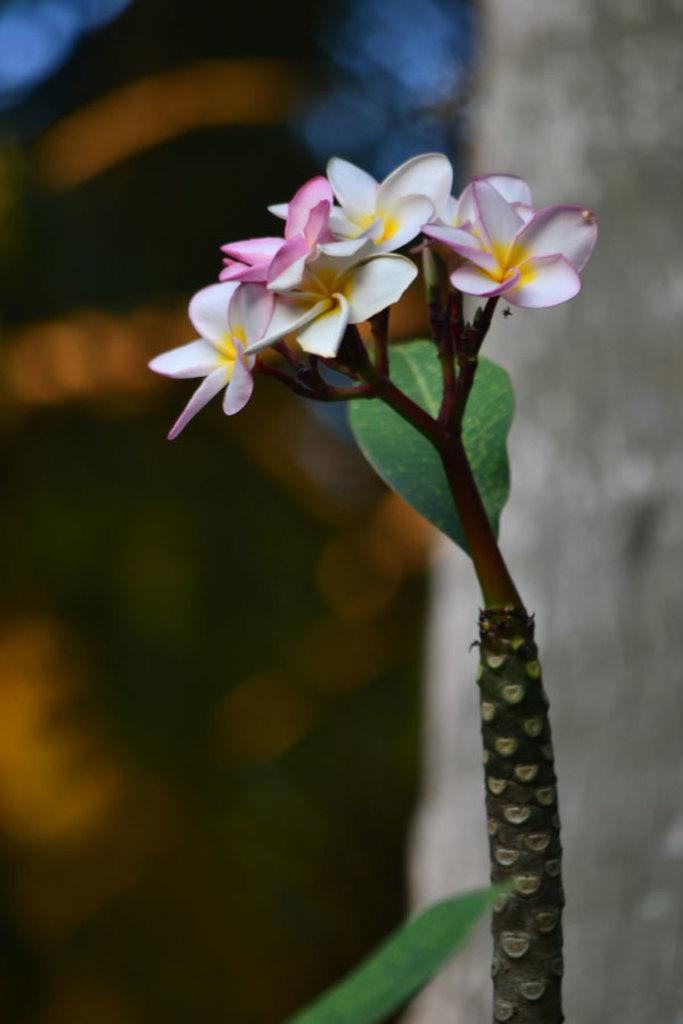What is the main subject of the image? There is a plant with flowers in the center of the image. Can you describe the background of the image? The background of the image is blurred. What type of mailbox can be seen in the image? There is no mailbox present in the image. What role does the key play in the ongoing war depicted in the image? There is no war or key present in the image. 